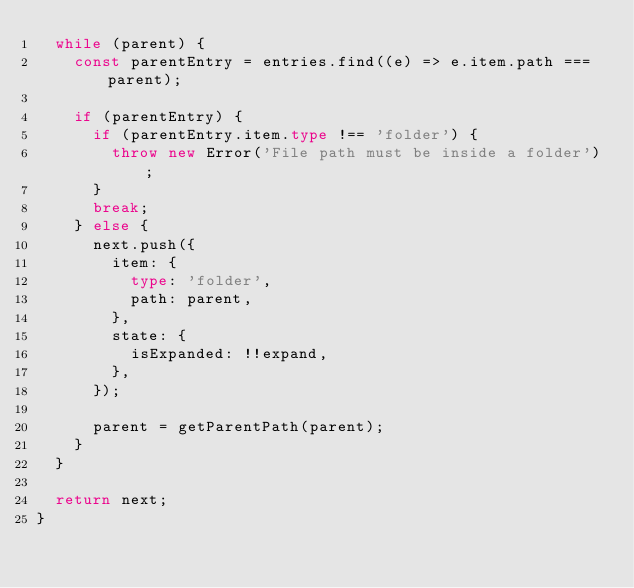Convert code to text. <code><loc_0><loc_0><loc_500><loc_500><_TypeScript_>  while (parent) {
    const parentEntry = entries.find((e) => e.item.path === parent);

    if (parentEntry) {
      if (parentEntry.item.type !== 'folder') {
        throw new Error('File path must be inside a folder');
      }
      break;
    } else {
      next.push({
        item: {
          type: 'folder',
          path: parent,
        },
        state: {
          isExpanded: !!expand,
        },
      });

      parent = getParentPath(parent);
    }
  }

  return next;
}
</code> 